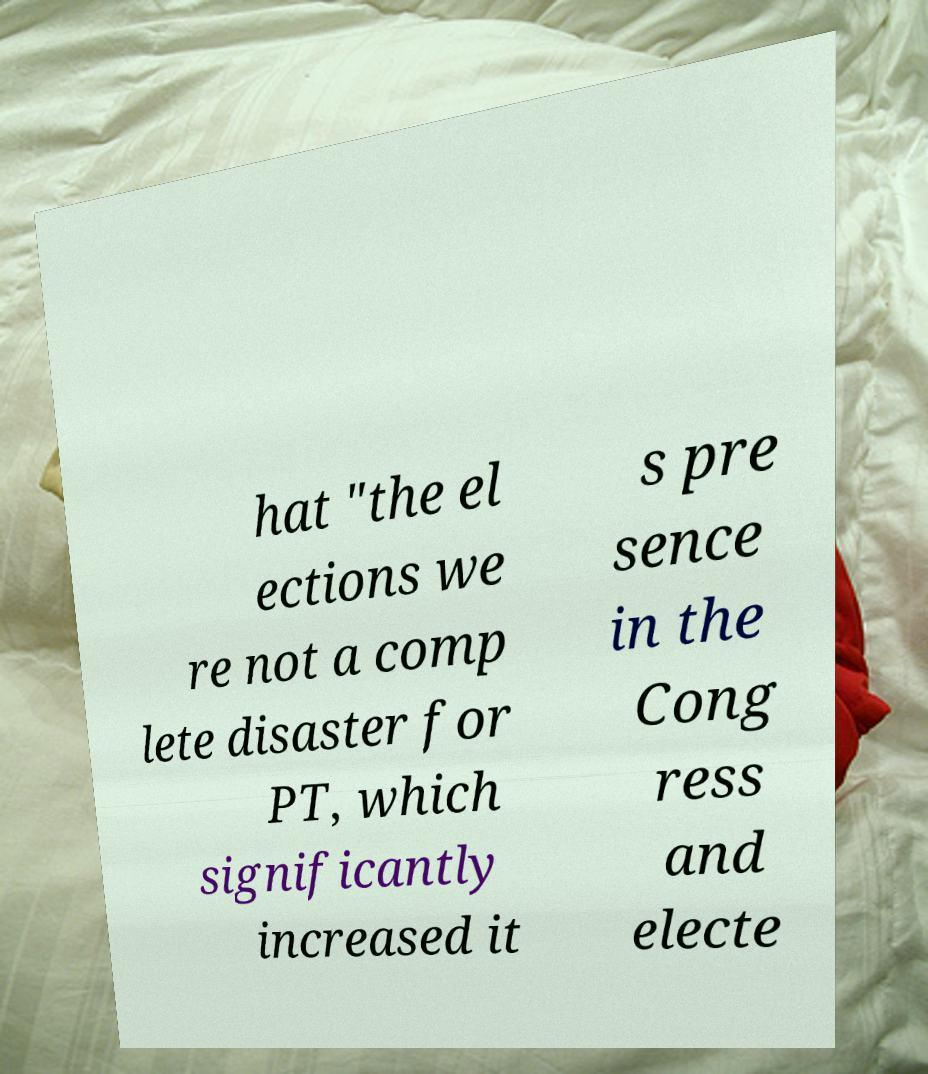Can you accurately transcribe the text from the provided image for me? hat "the el ections we re not a comp lete disaster for PT, which significantly increased it s pre sence in the Cong ress and electe 